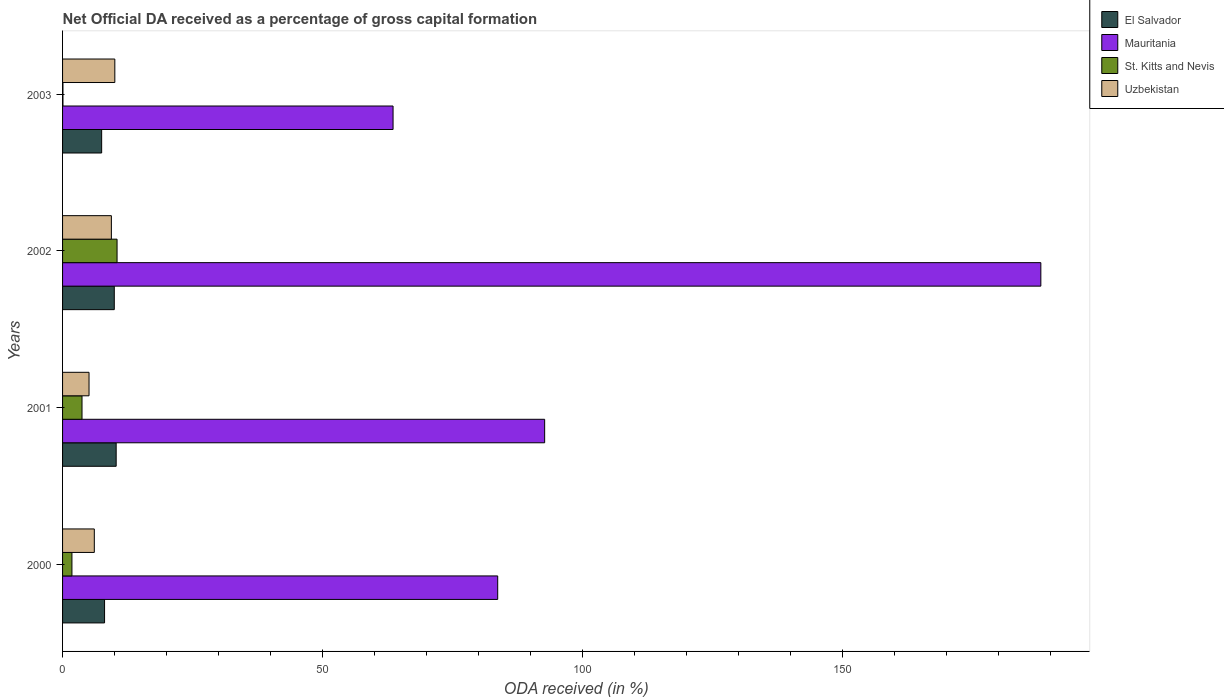Are the number of bars per tick equal to the number of legend labels?
Offer a very short reply. Yes. In how many cases, is the number of bars for a given year not equal to the number of legend labels?
Make the answer very short. 0. What is the net ODA received in St. Kitts and Nevis in 2003?
Offer a very short reply. 0.08. Across all years, what is the maximum net ODA received in Uzbekistan?
Your answer should be compact. 10.06. Across all years, what is the minimum net ODA received in Uzbekistan?
Your answer should be compact. 5.09. In which year was the net ODA received in Mauritania minimum?
Keep it short and to the point. 2003. What is the total net ODA received in St. Kitts and Nevis in the graph?
Offer a very short reply. 16.11. What is the difference between the net ODA received in St. Kitts and Nevis in 2000 and that in 2001?
Provide a succinct answer. -1.94. What is the difference between the net ODA received in Uzbekistan in 2000 and the net ODA received in St. Kitts and Nevis in 2001?
Offer a very short reply. 2.37. What is the average net ODA received in Mauritania per year?
Offer a very short reply. 107.08. In the year 2000, what is the difference between the net ODA received in Uzbekistan and net ODA received in Mauritania?
Keep it short and to the point. -77.62. In how many years, is the net ODA received in Uzbekistan greater than 40 %?
Provide a short and direct response. 0. What is the ratio of the net ODA received in St. Kitts and Nevis in 2000 to that in 2003?
Keep it short and to the point. 23.9. What is the difference between the highest and the second highest net ODA received in El Salvador?
Keep it short and to the point. 0.36. What is the difference between the highest and the lowest net ODA received in St. Kitts and Nevis?
Provide a succinct answer. 10.41. What does the 2nd bar from the top in 2001 represents?
Your answer should be very brief. St. Kitts and Nevis. What does the 2nd bar from the bottom in 2002 represents?
Your response must be concise. Mauritania. Is it the case that in every year, the sum of the net ODA received in St. Kitts and Nevis and net ODA received in Mauritania is greater than the net ODA received in Uzbekistan?
Provide a succinct answer. Yes. How many bars are there?
Offer a very short reply. 16. Are all the bars in the graph horizontal?
Your response must be concise. Yes. Are the values on the major ticks of X-axis written in scientific E-notation?
Make the answer very short. No. Does the graph contain any zero values?
Your response must be concise. No. Where does the legend appear in the graph?
Offer a very short reply. Top right. What is the title of the graph?
Offer a very short reply. Net Official DA received as a percentage of gross capital formation. What is the label or title of the X-axis?
Your answer should be very brief. ODA received (in %). What is the label or title of the Y-axis?
Offer a very short reply. Years. What is the ODA received (in %) in El Salvador in 2000?
Your response must be concise. 8.08. What is the ODA received (in %) of Mauritania in 2000?
Make the answer very short. 83.73. What is the ODA received (in %) in St. Kitts and Nevis in 2000?
Provide a short and direct response. 1.8. What is the ODA received (in %) in Uzbekistan in 2000?
Ensure brevity in your answer.  6.11. What is the ODA received (in %) in El Salvador in 2001?
Make the answer very short. 10.31. What is the ODA received (in %) in Mauritania in 2001?
Make the answer very short. 92.76. What is the ODA received (in %) of St. Kitts and Nevis in 2001?
Provide a succinct answer. 3.74. What is the ODA received (in %) in Uzbekistan in 2001?
Your answer should be very brief. 5.09. What is the ODA received (in %) of El Salvador in 2002?
Keep it short and to the point. 9.95. What is the ODA received (in %) in Mauritania in 2002?
Make the answer very short. 188.24. What is the ODA received (in %) in St. Kitts and Nevis in 2002?
Provide a succinct answer. 10.49. What is the ODA received (in %) in Uzbekistan in 2002?
Ensure brevity in your answer.  9.39. What is the ODA received (in %) of El Salvador in 2003?
Offer a very short reply. 7.52. What is the ODA received (in %) in Mauritania in 2003?
Offer a very short reply. 63.59. What is the ODA received (in %) of St. Kitts and Nevis in 2003?
Ensure brevity in your answer.  0.08. What is the ODA received (in %) of Uzbekistan in 2003?
Provide a short and direct response. 10.06. Across all years, what is the maximum ODA received (in %) in El Salvador?
Offer a terse response. 10.31. Across all years, what is the maximum ODA received (in %) in Mauritania?
Your answer should be very brief. 188.24. Across all years, what is the maximum ODA received (in %) in St. Kitts and Nevis?
Offer a very short reply. 10.49. Across all years, what is the maximum ODA received (in %) in Uzbekistan?
Your answer should be compact. 10.06. Across all years, what is the minimum ODA received (in %) of El Salvador?
Keep it short and to the point. 7.52. Across all years, what is the minimum ODA received (in %) in Mauritania?
Keep it short and to the point. 63.59. Across all years, what is the minimum ODA received (in %) in St. Kitts and Nevis?
Your answer should be very brief. 0.08. Across all years, what is the minimum ODA received (in %) in Uzbekistan?
Provide a succinct answer. 5.09. What is the total ODA received (in %) of El Salvador in the graph?
Your response must be concise. 35.87. What is the total ODA received (in %) of Mauritania in the graph?
Offer a very short reply. 428.32. What is the total ODA received (in %) in St. Kitts and Nevis in the graph?
Offer a terse response. 16.11. What is the total ODA received (in %) of Uzbekistan in the graph?
Offer a terse response. 30.65. What is the difference between the ODA received (in %) of El Salvador in 2000 and that in 2001?
Provide a succinct answer. -2.23. What is the difference between the ODA received (in %) in Mauritania in 2000 and that in 2001?
Offer a terse response. -9.03. What is the difference between the ODA received (in %) in St. Kitts and Nevis in 2000 and that in 2001?
Offer a terse response. -1.94. What is the difference between the ODA received (in %) of Uzbekistan in 2000 and that in 2001?
Offer a very short reply. 1.01. What is the difference between the ODA received (in %) of El Salvador in 2000 and that in 2002?
Your response must be concise. -1.87. What is the difference between the ODA received (in %) of Mauritania in 2000 and that in 2002?
Provide a succinct answer. -104.51. What is the difference between the ODA received (in %) in St. Kitts and Nevis in 2000 and that in 2002?
Keep it short and to the point. -8.68. What is the difference between the ODA received (in %) of Uzbekistan in 2000 and that in 2002?
Offer a terse response. -3.28. What is the difference between the ODA received (in %) of El Salvador in 2000 and that in 2003?
Your answer should be compact. 0.56. What is the difference between the ODA received (in %) in Mauritania in 2000 and that in 2003?
Your response must be concise. 20.13. What is the difference between the ODA received (in %) of St. Kitts and Nevis in 2000 and that in 2003?
Provide a succinct answer. 1.73. What is the difference between the ODA received (in %) of Uzbekistan in 2000 and that in 2003?
Your response must be concise. -3.95. What is the difference between the ODA received (in %) in El Salvador in 2001 and that in 2002?
Offer a very short reply. 0.36. What is the difference between the ODA received (in %) of Mauritania in 2001 and that in 2002?
Provide a succinct answer. -95.48. What is the difference between the ODA received (in %) of St. Kitts and Nevis in 2001 and that in 2002?
Your answer should be compact. -6.74. What is the difference between the ODA received (in %) in Uzbekistan in 2001 and that in 2002?
Keep it short and to the point. -4.3. What is the difference between the ODA received (in %) in El Salvador in 2001 and that in 2003?
Your response must be concise. 2.79. What is the difference between the ODA received (in %) of Mauritania in 2001 and that in 2003?
Your answer should be very brief. 29.17. What is the difference between the ODA received (in %) of St. Kitts and Nevis in 2001 and that in 2003?
Provide a succinct answer. 3.67. What is the difference between the ODA received (in %) in Uzbekistan in 2001 and that in 2003?
Provide a succinct answer. -4.96. What is the difference between the ODA received (in %) in El Salvador in 2002 and that in 2003?
Make the answer very short. 2.43. What is the difference between the ODA received (in %) in Mauritania in 2002 and that in 2003?
Keep it short and to the point. 124.64. What is the difference between the ODA received (in %) of St. Kitts and Nevis in 2002 and that in 2003?
Ensure brevity in your answer.  10.41. What is the difference between the ODA received (in %) in Uzbekistan in 2002 and that in 2003?
Provide a short and direct response. -0.67. What is the difference between the ODA received (in %) of El Salvador in 2000 and the ODA received (in %) of Mauritania in 2001?
Your answer should be compact. -84.68. What is the difference between the ODA received (in %) of El Salvador in 2000 and the ODA received (in %) of St. Kitts and Nevis in 2001?
Your answer should be compact. 4.34. What is the difference between the ODA received (in %) of El Salvador in 2000 and the ODA received (in %) of Uzbekistan in 2001?
Provide a short and direct response. 2.99. What is the difference between the ODA received (in %) in Mauritania in 2000 and the ODA received (in %) in St. Kitts and Nevis in 2001?
Make the answer very short. 79.99. What is the difference between the ODA received (in %) of Mauritania in 2000 and the ODA received (in %) of Uzbekistan in 2001?
Provide a short and direct response. 78.64. What is the difference between the ODA received (in %) of St. Kitts and Nevis in 2000 and the ODA received (in %) of Uzbekistan in 2001?
Your answer should be compact. -3.29. What is the difference between the ODA received (in %) of El Salvador in 2000 and the ODA received (in %) of Mauritania in 2002?
Give a very brief answer. -180.16. What is the difference between the ODA received (in %) in El Salvador in 2000 and the ODA received (in %) in St. Kitts and Nevis in 2002?
Your answer should be compact. -2.4. What is the difference between the ODA received (in %) in El Salvador in 2000 and the ODA received (in %) in Uzbekistan in 2002?
Provide a short and direct response. -1.31. What is the difference between the ODA received (in %) of Mauritania in 2000 and the ODA received (in %) of St. Kitts and Nevis in 2002?
Give a very brief answer. 73.24. What is the difference between the ODA received (in %) of Mauritania in 2000 and the ODA received (in %) of Uzbekistan in 2002?
Provide a succinct answer. 74.34. What is the difference between the ODA received (in %) of St. Kitts and Nevis in 2000 and the ODA received (in %) of Uzbekistan in 2002?
Your answer should be very brief. -7.59. What is the difference between the ODA received (in %) of El Salvador in 2000 and the ODA received (in %) of Mauritania in 2003?
Provide a short and direct response. -55.51. What is the difference between the ODA received (in %) in El Salvador in 2000 and the ODA received (in %) in St. Kitts and Nevis in 2003?
Make the answer very short. 8.01. What is the difference between the ODA received (in %) in El Salvador in 2000 and the ODA received (in %) in Uzbekistan in 2003?
Your answer should be very brief. -1.98. What is the difference between the ODA received (in %) in Mauritania in 2000 and the ODA received (in %) in St. Kitts and Nevis in 2003?
Your answer should be compact. 83.65. What is the difference between the ODA received (in %) in Mauritania in 2000 and the ODA received (in %) in Uzbekistan in 2003?
Ensure brevity in your answer.  73.67. What is the difference between the ODA received (in %) in St. Kitts and Nevis in 2000 and the ODA received (in %) in Uzbekistan in 2003?
Provide a succinct answer. -8.25. What is the difference between the ODA received (in %) of El Salvador in 2001 and the ODA received (in %) of Mauritania in 2002?
Your response must be concise. -177.92. What is the difference between the ODA received (in %) of El Salvador in 2001 and the ODA received (in %) of St. Kitts and Nevis in 2002?
Provide a succinct answer. -0.17. What is the difference between the ODA received (in %) in El Salvador in 2001 and the ODA received (in %) in Uzbekistan in 2002?
Ensure brevity in your answer.  0.92. What is the difference between the ODA received (in %) of Mauritania in 2001 and the ODA received (in %) of St. Kitts and Nevis in 2002?
Your answer should be compact. 82.28. What is the difference between the ODA received (in %) of Mauritania in 2001 and the ODA received (in %) of Uzbekistan in 2002?
Provide a short and direct response. 83.37. What is the difference between the ODA received (in %) of St. Kitts and Nevis in 2001 and the ODA received (in %) of Uzbekistan in 2002?
Your answer should be very brief. -5.65. What is the difference between the ODA received (in %) in El Salvador in 2001 and the ODA received (in %) in Mauritania in 2003?
Provide a short and direct response. -53.28. What is the difference between the ODA received (in %) in El Salvador in 2001 and the ODA received (in %) in St. Kitts and Nevis in 2003?
Make the answer very short. 10.24. What is the difference between the ODA received (in %) of El Salvador in 2001 and the ODA received (in %) of Uzbekistan in 2003?
Offer a very short reply. 0.26. What is the difference between the ODA received (in %) of Mauritania in 2001 and the ODA received (in %) of St. Kitts and Nevis in 2003?
Give a very brief answer. 92.69. What is the difference between the ODA received (in %) of Mauritania in 2001 and the ODA received (in %) of Uzbekistan in 2003?
Your answer should be very brief. 82.71. What is the difference between the ODA received (in %) in St. Kitts and Nevis in 2001 and the ODA received (in %) in Uzbekistan in 2003?
Ensure brevity in your answer.  -6.31. What is the difference between the ODA received (in %) in El Salvador in 2002 and the ODA received (in %) in Mauritania in 2003?
Ensure brevity in your answer.  -53.64. What is the difference between the ODA received (in %) in El Salvador in 2002 and the ODA received (in %) in St. Kitts and Nevis in 2003?
Your answer should be compact. 9.88. What is the difference between the ODA received (in %) of El Salvador in 2002 and the ODA received (in %) of Uzbekistan in 2003?
Offer a very short reply. -0.11. What is the difference between the ODA received (in %) of Mauritania in 2002 and the ODA received (in %) of St. Kitts and Nevis in 2003?
Your answer should be very brief. 188.16. What is the difference between the ODA received (in %) of Mauritania in 2002 and the ODA received (in %) of Uzbekistan in 2003?
Provide a short and direct response. 178.18. What is the difference between the ODA received (in %) of St. Kitts and Nevis in 2002 and the ODA received (in %) of Uzbekistan in 2003?
Provide a succinct answer. 0.43. What is the average ODA received (in %) in El Salvador per year?
Keep it short and to the point. 8.97. What is the average ODA received (in %) in Mauritania per year?
Offer a terse response. 107.08. What is the average ODA received (in %) in St. Kitts and Nevis per year?
Offer a very short reply. 4.03. What is the average ODA received (in %) of Uzbekistan per year?
Make the answer very short. 7.66. In the year 2000, what is the difference between the ODA received (in %) of El Salvador and ODA received (in %) of Mauritania?
Your answer should be very brief. -75.65. In the year 2000, what is the difference between the ODA received (in %) of El Salvador and ODA received (in %) of St. Kitts and Nevis?
Your answer should be very brief. 6.28. In the year 2000, what is the difference between the ODA received (in %) of El Salvador and ODA received (in %) of Uzbekistan?
Provide a short and direct response. 1.97. In the year 2000, what is the difference between the ODA received (in %) in Mauritania and ODA received (in %) in St. Kitts and Nevis?
Your response must be concise. 81.93. In the year 2000, what is the difference between the ODA received (in %) of Mauritania and ODA received (in %) of Uzbekistan?
Offer a very short reply. 77.62. In the year 2000, what is the difference between the ODA received (in %) of St. Kitts and Nevis and ODA received (in %) of Uzbekistan?
Offer a very short reply. -4.31. In the year 2001, what is the difference between the ODA received (in %) in El Salvador and ODA received (in %) in Mauritania?
Your answer should be compact. -82.45. In the year 2001, what is the difference between the ODA received (in %) in El Salvador and ODA received (in %) in St. Kitts and Nevis?
Offer a very short reply. 6.57. In the year 2001, what is the difference between the ODA received (in %) of El Salvador and ODA received (in %) of Uzbekistan?
Ensure brevity in your answer.  5.22. In the year 2001, what is the difference between the ODA received (in %) of Mauritania and ODA received (in %) of St. Kitts and Nevis?
Make the answer very short. 89.02. In the year 2001, what is the difference between the ODA received (in %) in Mauritania and ODA received (in %) in Uzbekistan?
Offer a very short reply. 87.67. In the year 2001, what is the difference between the ODA received (in %) of St. Kitts and Nevis and ODA received (in %) of Uzbekistan?
Make the answer very short. -1.35. In the year 2002, what is the difference between the ODA received (in %) in El Salvador and ODA received (in %) in Mauritania?
Make the answer very short. -178.29. In the year 2002, what is the difference between the ODA received (in %) of El Salvador and ODA received (in %) of St. Kitts and Nevis?
Make the answer very short. -0.54. In the year 2002, what is the difference between the ODA received (in %) of El Salvador and ODA received (in %) of Uzbekistan?
Make the answer very short. 0.56. In the year 2002, what is the difference between the ODA received (in %) of Mauritania and ODA received (in %) of St. Kitts and Nevis?
Provide a short and direct response. 177.75. In the year 2002, what is the difference between the ODA received (in %) in Mauritania and ODA received (in %) in Uzbekistan?
Provide a short and direct response. 178.85. In the year 2002, what is the difference between the ODA received (in %) in St. Kitts and Nevis and ODA received (in %) in Uzbekistan?
Give a very brief answer. 1.09. In the year 2003, what is the difference between the ODA received (in %) in El Salvador and ODA received (in %) in Mauritania?
Offer a terse response. -56.07. In the year 2003, what is the difference between the ODA received (in %) in El Salvador and ODA received (in %) in St. Kitts and Nevis?
Keep it short and to the point. 7.44. In the year 2003, what is the difference between the ODA received (in %) in El Salvador and ODA received (in %) in Uzbekistan?
Your answer should be compact. -2.54. In the year 2003, what is the difference between the ODA received (in %) of Mauritania and ODA received (in %) of St. Kitts and Nevis?
Keep it short and to the point. 63.52. In the year 2003, what is the difference between the ODA received (in %) in Mauritania and ODA received (in %) in Uzbekistan?
Your answer should be compact. 53.54. In the year 2003, what is the difference between the ODA received (in %) in St. Kitts and Nevis and ODA received (in %) in Uzbekistan?
Your response must be concise. -9.98. What is the ratio of the ODA received (in %) in El Salvador in 2000 to that in 2001?
Keep it short and to the point. 0.78. What is the ratio of the ODA received (in %) of Mauritania in 2000 to that in 2001?
Keep it short and to the point. 0.9. What is the ratio of the ODA received (in %) in St. Kitts and Nevis in 2000 to that in 2001?
Provide a short and direct response. 0.48. What is the ratio of the ODA received (in %) of Uzbekistan in 2000 to that in 2001?
Provide a short and direct response. 1.2. What is the ratio of the ODA received (in %) in El Salvador in 2000 to that in 2002?
Keep it short and to the point. 0.81. What is the ratio of the ODA received (in %) in Mauritania in 2000 to that in 2002?
Offer a very short reply. 0.44. What is the ratio of the ODA received (in %) of St. Kitts and Nevis in 2000 to that in 2002?
Your response must be concise. 0.17. What is the ratio of the ODA received (in %) in Uzbekistan in 2000 to that in 2002?
Offer a very short reply. 0.65. What is the ratio of the ODA received (in %) of El Salvador in 2000 to that in 2003?
Keep it short and to the point. 1.07. What is the ratio of the ODA received (in %) of Mauritania in 2000 to that in 2003?
Offer a very short reply. 1.32. What is the ratio of the ODA received (in %) of St. Kitts and Nevis in 2000 to that in 2003?
Your response must be concise. 23.9. What is the ratio of the ODA received (in %) in Uzbekistan in 2000 to that in 2003?
Your answer should be very brief. 0.61. What is the ratio of the ODA received (in %) in El Salvador in 2001 to that in 2002?
Give a very brief answer. 1.04. What is the ratio of the ODA received (in %) in Mauritania in 2001 to that in 2002?
Offer a terse response. 0.49. What is the ratio of the ODA received (in %) of St. Kitts and Nevis in 2001 to that in 2002?
Provide a succinct answer. 0.36. What is the ratio of the ODA received (in %) in Uzbekistan in 2001 to that in 2002?
Your response must be concise. 0.54. What is the ratio of the ODA received (in %) of El Salvador in 2001 to that in 2003?
Ensure brevity in your answer.  1.37. What is the ratio of the ODA received (in %) of Mauritania in 2001 to that in 2003?
Offer a terse response. 1.46. What is the ratio of the ODA received (in %) of St. Kitts and Nevis in 2001 to that in 2003?
Ensure brevity in your answer.  49.62. What is the ratio of the ODA received (in %) in Uzbekistan in 2001 to that in 2003?
Your answer should be very brief. 0.51. What is the ratio of the ODA received (in %) of El Salvador in 2002 to that in 2003?
Ensure brevity in your answer.  1.32. What is the ratio of the ODA received (in %) of Mauritania in 2002 to that in 2003?
Ensure brevity in your answer.  2.96. What is the ratio of the ODA received (in %) in St. Kitts and Nevis in 2002 to that in 2003?
Provide a succinct answer. 139.06. What is the ratio of the ODA received (in %) in Uzbekistan in 2002 to that in 2003?
Keep it short and to the point. 0.93. What is the difference between the highest and the second highest ODA received (in %) in El Salvador?
Your answer should be very brief. 0.36. What is the difference between the highest and the second highest ODA received (in %) in Mauritania?
Your answer should be compact. 95.48. What is the difference between the highest and the second highest ODA received (in %) in St. Kitts and Nevis?
Ensure brevity in your answer.  6.74. What is the difference between the highest and the second highest ODA received (in %) in Uzbekistan?
Your answer should be compact. 0.67. What is the difference between the highest and the lowest ODA received (in %) in El Salvador?
Make the answer very short. 2.79. What is the difference between the highest and the lowest ODA received (in %) of Mauritania?
Ensure brevity in your answer.  124.64. What is the difference between the highest and the lowest ODA received (in %) of St. Kitts and Nevis?
Provide a short and direct response. 10.41. What is the difference between the highest and the lowest ODA received (in %) of Uzbekistan?
Keep it short and to the point. 4.96. 